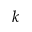<formula> <loc_0><loc_0><loc_500><loc_500>k</formula> 